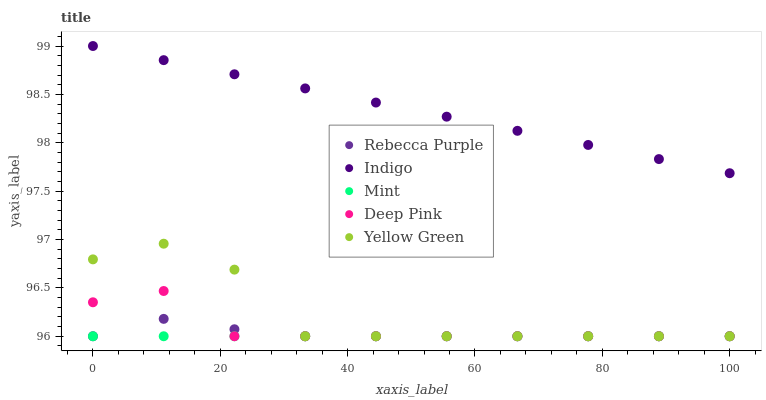Does Mint have the minimum area under the curve?
Answer yes or no. Yes. Does Indigo have the maximum area under the curve?
Answer yes or no. Yes. Does Deep Pink have the minimum area under the curve?
Answer yes or no. No. Does Deep Pink have the maximum area under the curve?
Answer yes or no. No. Is Mint the smoothest?
Answer yes or no. Yes. Is Yellow Green the roughest?
Answer yes or no. Yes. Is Deep Pink the smoothest?
Answer yes or no. No. Is Deep Pink the roughest?
Answer yes or no. No. Does Mint have the lowest value?
Answer yes or no. Yes. Does Indigo have the lowest value?
Answer yes or no. No. Does Indigo have the highest value?
Answer yes or no. Yes. Does Deep Pink have the highest value?
Answer yes or no. No. Is Deep Pink less than Indigo?
Answer yes or no. Yes. Is Indigo greater than Yellow Green?
Answer yes or no. Yes. Does Rebecca Purple intersect Deep Pink?
Answer yes or no. Yes. Is Rebecca Purple less than Deep Pink?
Answer yes or no. No. Is Rebecca Purple greater than Deep Pink?
Answer yes or no. No. Does Deep Pink intersect Indigo?
Answer yes or no. No. 